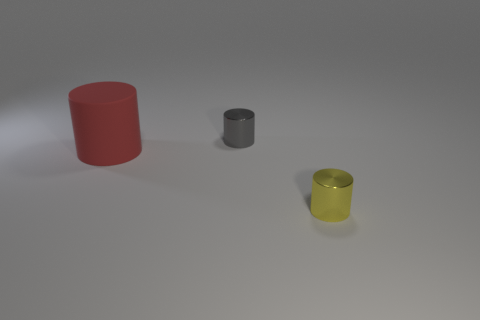Is there anything else that has the same material as the big red cylinder?
Offer a very short reply. No. Are there any other things that are the same size as the red rubber cylinder?
Your answer should be compact. No. There is a small cylinder in front of the red rubber object; is it the same color as the cylinder behind the matte object?
Provide a short and direct response. No. There is a thing that is both right of the large red object and in front of the tiny gray cylinder; what is its shape?
Give a very brief answer. Cylinder. Are there any other metal objects that have the same shape as the small yellow object?
Your answer should be compact. Yes. What is the shape of the other object that is the same size as the gray thing?
Your response must be concise. Cylinder. What material is the big red cylinder?
Keep it short and to the point. Rubber. What size is the yellow object in front of the tiny object that is behind the metallic cylinder in front of the rubber thing?
Provide a succinct answer. Small. How many metallic objects are large red cylinders or gray things?
Your answer should be compact. 1. What is the size of the yellow cylinder?
Keep it short and to the point. Small. 